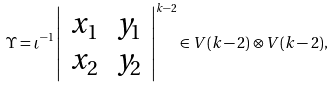<formula> <loc_0><loc_0><loc_500><loc_500>\Upsilon = \iota ^ { - 1 } \left | \begin{array} { c c } x _ { 1 } & y _ { 1 } \\ x _ { 2 } & y _ { 2 } \end{array} \right | ^ { k - 2 } \in V ( k - 2 ) \otimes V ( k - 2 ) ,</formula> 